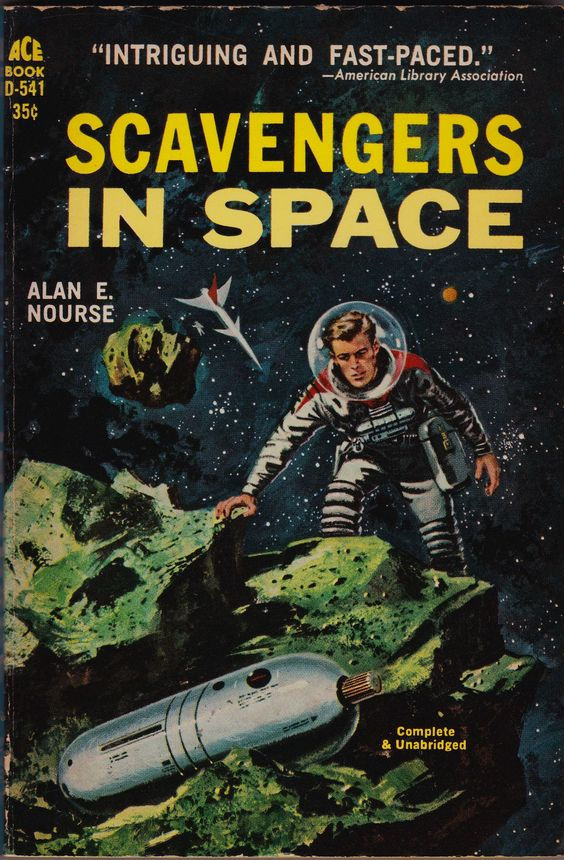describe esta imagen con todo lujo de detalles
 La imagen muestra la portada de un libro de ciencia ficción de los años 50, con un astronauta en un planeta alienígena. El astronauta lleva un traje espacial blanco y un casco, y está de pie sobre una roca. En el fondo hay un paisaje montañoso, con una nave espacial en la distancia. El cielo está lleno de estrellas. El título del libro es "Scavengers in Space" y el autor es Alan E. Nourse. with this description write in english a complete stable diffusion prompt to really portray the image: ""La imagen muestra la portada de un libro titulado "Scavengers in Space" por Alan E. Nourse. La portada tiene un diseño clásico de ciencia ficción del siglo XX.

Descripción detallada:

Texto en la parte superior:

En la esquina superior izquierda, en letras amarillas, se lee "ACE BOOK D-541".
Justo debajo, también en amarillo, está el precio "35¢".
En la parte superior central, hay una cita en letras blancas: "INTRIGUING AND FAST-PACED." seguida de "-American Library Association".
Título:

El título "SCAVENGERS IN SPACE" está en letras grandes y amarillas en el centro de la portada. La palabra "SCAVENGERS" está en la parte superior y "IN SPACE" justo debajo.
Autor:

A la izquierda del título, en letras blancas más pequeñas, se lee "ALAN E. NOURSE".
Ilustración:

La ilustración muestra a un astronauta en un traje espacial clásico, completo con un casco redondo transparente. El astronauta es un hombre de cabello claro que parece estar explorando una superficie rocosa.
El astronauta está en una postura inclinada, con una mano tocando una roca verde y la otra sosteniendo lo que parece ser un dispositivo o herramienta.
La escena ocurre en el espacio exterior, con un fondo estrellado y oscuro.
Hay asteroides o rocas espaciales flotando alrededor.
En la parte superior izquierda, cerca del astronauta, hay una nave espacial pequeña y puntiaguda volando.
En la parte inferior de la ilustración, se ve una cápsula espacial plateada, parcialmente enterrada en las rocas verdes.
Texto adicional:

En la esquina inferior derecha, en letras amarillas, se lee "Complete & Unabridged".
La portada logra transmitir una sensación de aventura y exploración espacial, típica de las novelas de ciencia ficción de la época."" /imagine: prompt: cover of a book titled "Scavengers in Space" by Alan E. Nourse. The cover has a classic 20th century science fiction design.

Detailed description:

Text on top:

On the top left corner, in yellow letters, it reads "ACE BOOK D-541".
Right beneath, also in yellow, is the price "35¢".
On the top center, there's a quote in white letters: "INTRIGUING AND FAST-PACED." followed by "-American Library Association".
Title:

The title "SCAVENGERS IN SPACE" is in big, yellow letters on the center of the cover. The word "SCAVENGERS" is on top and "IN SPACE" right underneath.
Author:

To the left of the title, in smaller white letters, reads "ALAN E. NOURSE".
Illustration:

The illustration shows an astronaut in a classic spacesuit, complete with a round transparent helmet. The astronaut is a blond man who seems to be exploring a rocky surface.
The astronaut is in a leaning pose, with one hand touching a green rock and the other holding what seems to be a device or tool.
The scene takes place in outer space, with a dark starry background.
There are asteroids or space rocks floating around.
On the top left, near the astronaut, there's a small and pointy spaceship flying.
On the bottom of the illustration, a silver space capsule is seen, partially buried on the green rocks.
Additional text:

On the bottom right corner, in yellow letters, reads "Complete & Unabridged".
The cover manages to convey a sense of adventure and space exploration, typical of the sci-fi novels of the era. 